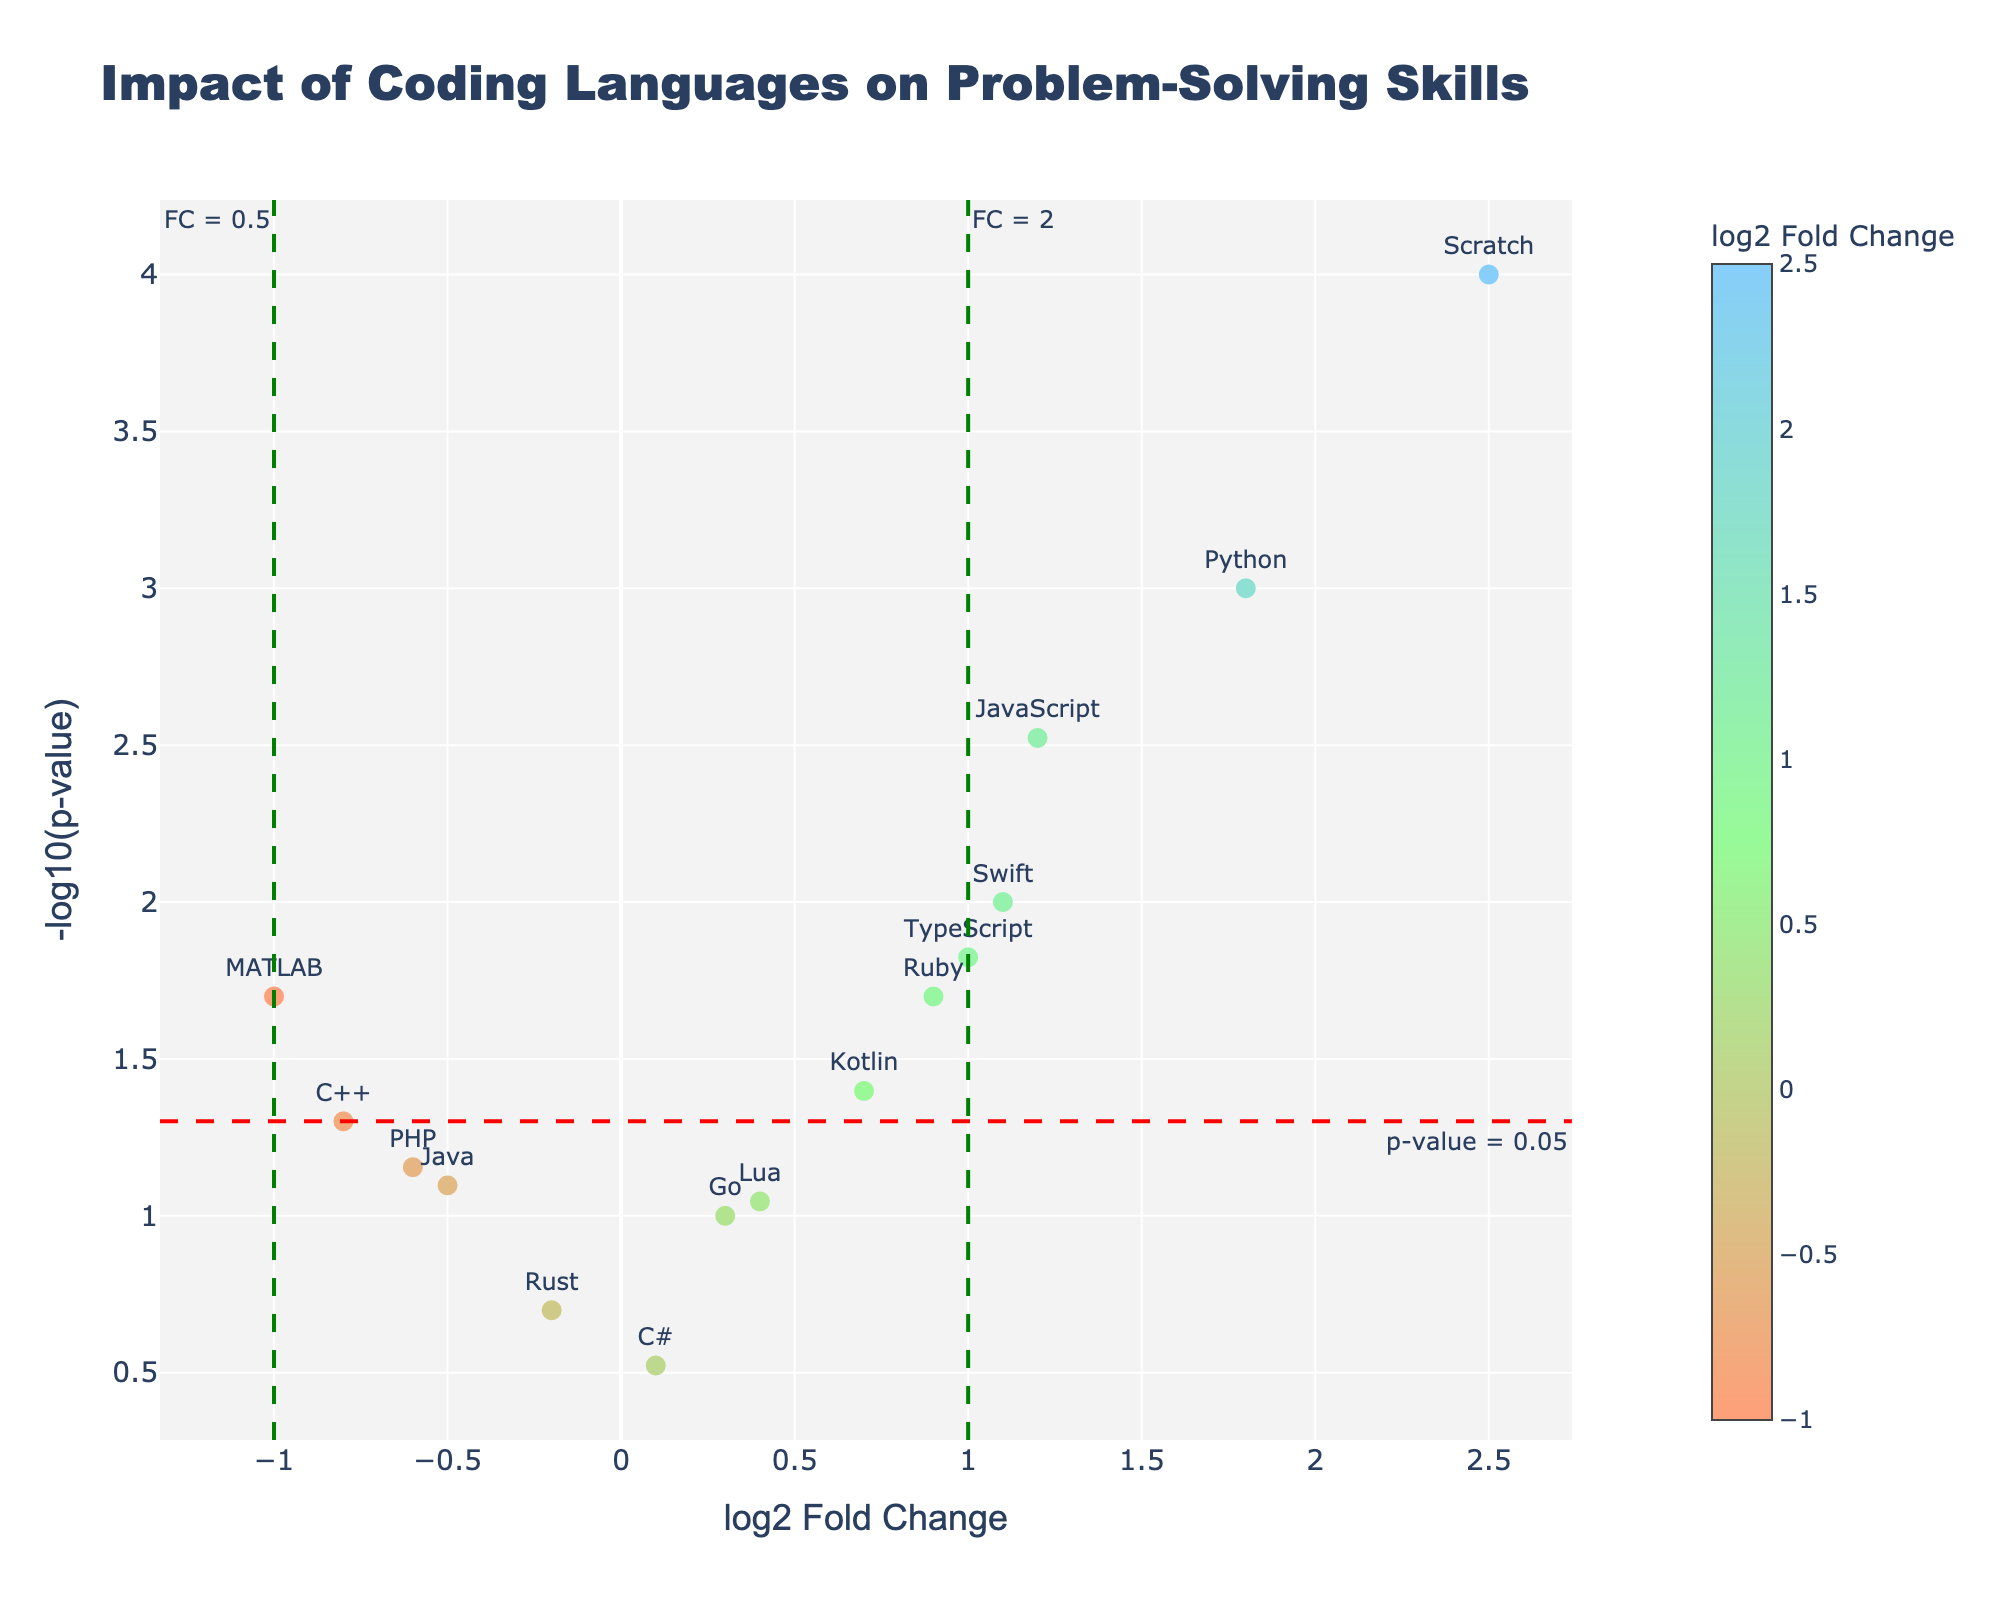Which coding language has the highest log2 fold change? Look at the x-axis for the coding language that has the highest value. Scratch has the highest log2 fold change with a value of 2.5.
Answer: Scratch Which coding language has the lowest p-value? Check the y-axis for the coding language with the highest -log10(p-value) because a higher -log10(p-value) corresponds to a lower p-value. Scratch has the highest -log10(p-value), indicating the lowest p-value of 0.0001.
Answer: Scratch Which languages have a significant p-value (below 0.05)? Look for data points above the red horizontal line (p-value threshold of 0.05). The languages are Python, JavaScript, Scratch, Ruby, Swift, TypeScript, MATLAB, and Kotlin.
Answer: Python, JavaScript, Scratch, Ruby, Swift, TypeScript, MATLAB, Kotlin How many coding languages fall into the category of having significant p-values? Count the number of data points above the red horizontal line which denotes p-values below 0.05. There are 8 languages above this line.
Answer: 8 Which coding languages both improve problem-solving speed and have statistically significant p-values? Look for coding languages in the right half of the plot (log2 fold change > 0) and above the red horizontal line (-log10(p-value) corresponding to p-value < 0.05). The languages are Python, JavaScript, Scratch, Ruby, Swift, and TypeScript.
Answer: Python, JavaScript, Scratch, Ruby, Swift, TypeScript What is the log2 fold change value for Java and MATLAB, and which one has more impact on problem-solving speed? Check the x-axis values for Java and MATLAB. Java has a log2 fold change of -0.5, and MATLAB has -1.0. MATLAB has a more negative impact as its value is lower.
Answer: Java: -0.5, MATLAB: -1.0, MATLAB has more impact Which coding languages are close to the non-significant p-value threshold but have a notable log2 fold change? Identify points near the red horizontal line (-log10(p-value) = 1.3) but have higher or lower log2 fold changes. Kotlin (0.7), C++ (-0.8), and PHP (-0.6) are close to the threshold with noticeable fold changes.
Answer: Kotlin, C++, PHP Which coding languages do not significantly affect problem-solving speed and accuracy (p-value >= 0.05)? Look for coding languages below the red horizontal line since a p-value >= 0.05 is not significant. These languages are Java, C++, Go, Rust, Lua, PHP, and C#.
Answer: Java, C++, Go, Rust, Lua, PHP, C# Is there a coding language that significantly reduces problem-solving speed and accuracy? Check the left half of the plot (log2 fold change < 0) and above the red horizontal line (-log10(p-value) corresponding to p-value < 0.05). MATLAB is the language that meets both conditions with a log2 fold change of -1.0.
Answer: MATLAB 